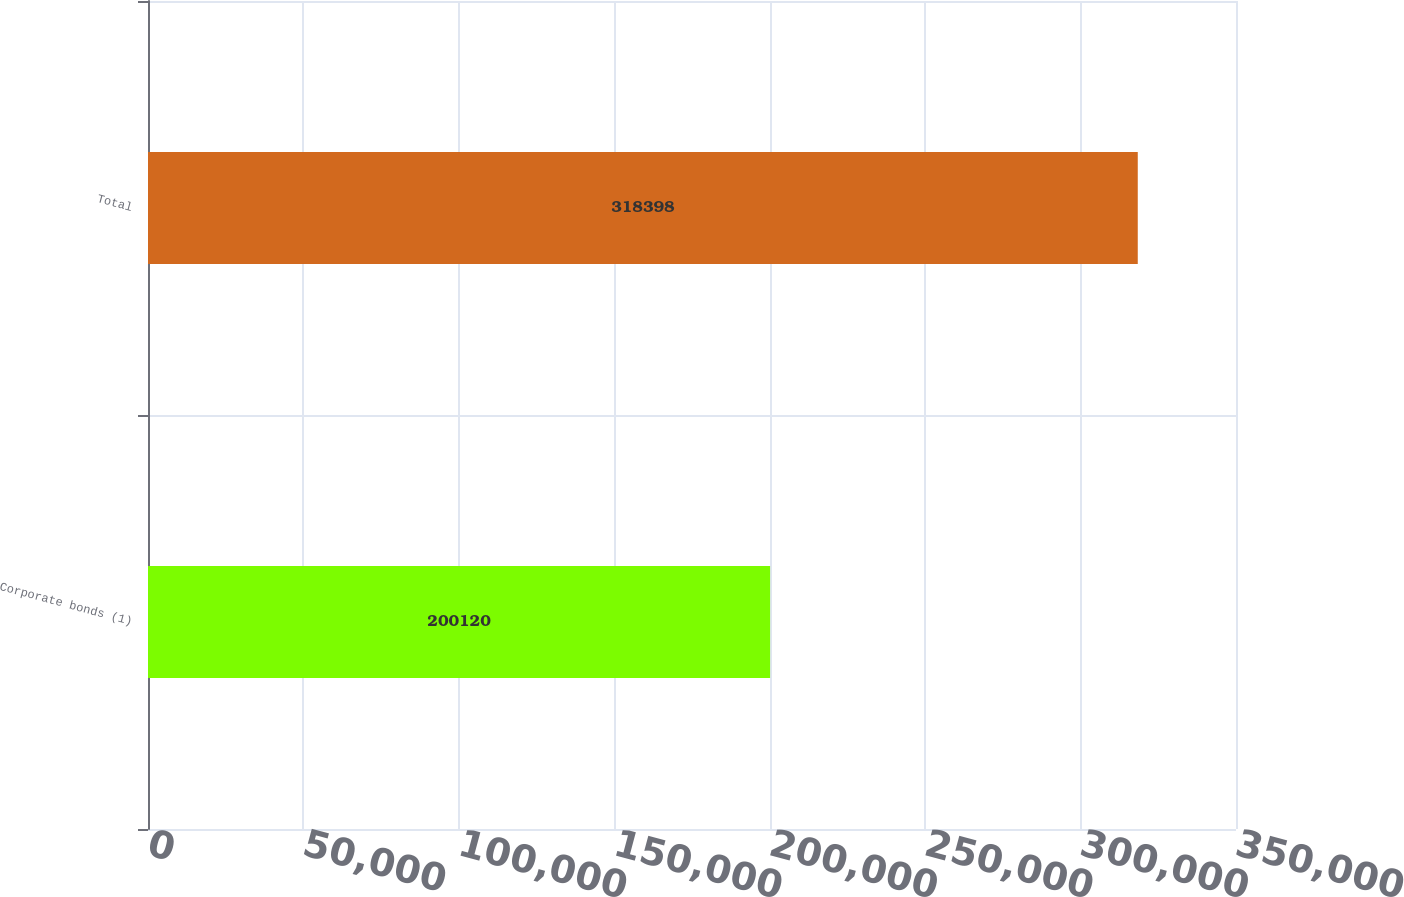Convert chart to OTSL. <chart><loc_0><loc_0><loc_500><loc_500><bar_chart><fcel>Corporate bonds (1)<fcel>Total<nl><fcel>200120<fcel>318398<nl></chart> 